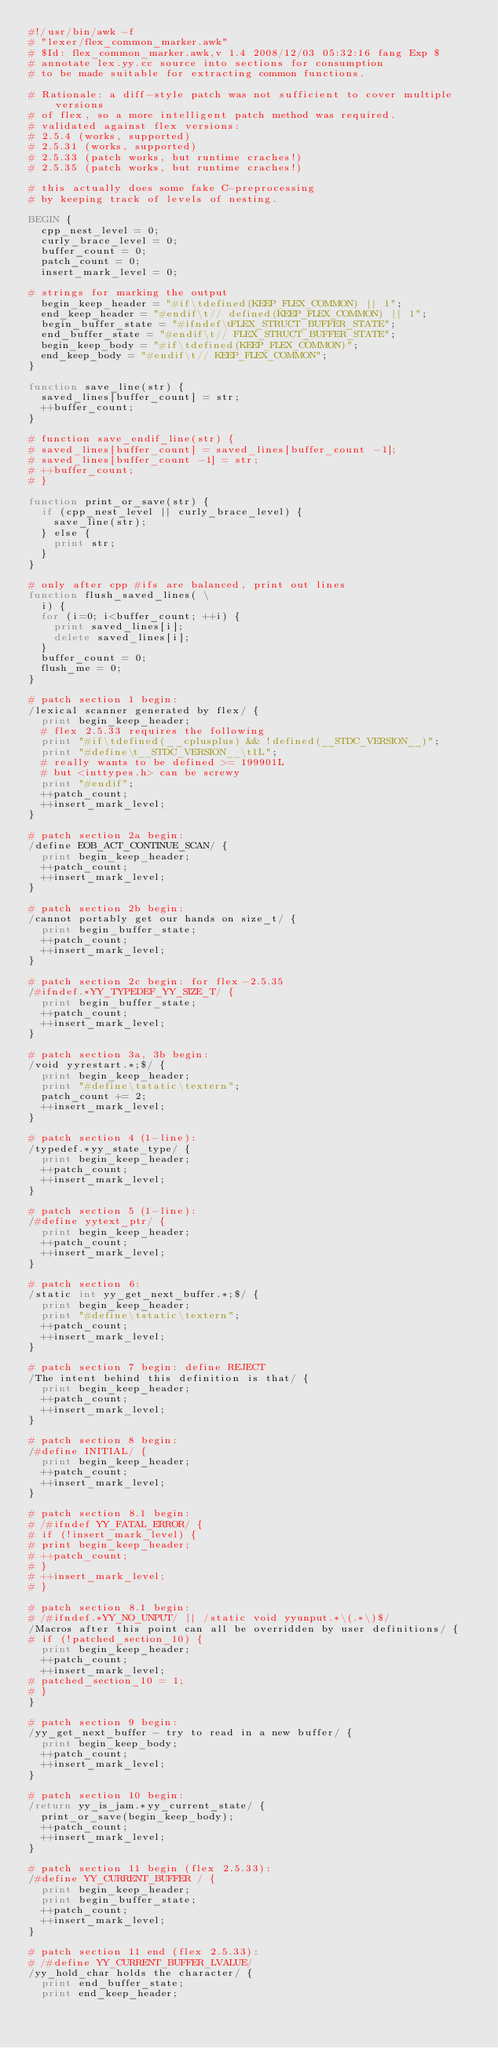Convert code to text. <code><loc_0><loc_0><loc_500><loc_500><_Awk_>#!/usr/bin/awk -f
# "lexer/flex_common_marker.awk"
#	$Id: flex_common_marker.awk,v 1.4 2008/12/03 05:32:16 fang Exp $
# annotate lex.yy.cc source into sections for consumption
# to be made suitable for extracting common functions.

# Rationale: a diff-style patch was not sufficient to cover multiple versions 
# of flex, so a more intelligent patch method was required.  
# validated against flex versions:
# 2.5.4 (works, supported)
# 2.5.31 (works, supported)
# 2.5.33 (patch works, but runtime craches!)
# 2.5.35 (patch works, but runtime craches!)

# this actually does some fake C-preprocessing
# by keeping track of levels of nesting.

BEGIN {
	cpp_nest_level = 0;
	curly_brace_level = 0;
	buffer_count = 0;
	patch_count = 0;
	insert_mark_level = 0;

# strings for marking the output
	begin_keep_header = "#if\tdefined(KEEP_FLEX_COMMON) || 1";
	end_keep_header = "#endif\t// defined(KEEP_FLEX_COMMON) || 1";
	begin_buffer_state = "#ifndef\tFLEX_STRUCT_BUFFER_STATE";
	end_buffer_state = "#endif\t// FLEX_STRUCT_BUFFER_STATE";
	begin_keep_body = "#if\tdefined(KEEP_FLEX_COMMON)";
	end_keep_body = "#endif\t// KEEP_FLEX_COMMON";
}

function save_line(str) {
	saved_lines[buffer_count] = str;
	++buffer_count;
}

# function save_endif_line(str) {
#	saved_lines[buffer_count] = saved_lines[buffer_count -1];
#	saved_lines[buffer_count -1] = str;
#	++buffer_count;
# }

function print_or_save(str) {
	if (cpp_nest_level || curly_brace_level) {
		save_line(str);
	} else {
		print str;
	}
}

# only after cpp #ifs are balanced, print out lines
function flush_saved_lines( \
	i) {
	for (i=0; i<buffer_count; ++i) {
		print saved_lines[i];
		delete saved_lines[i];
	}
	buffer_count = 0;
	flush_me = 0;
}

# patch section 1 begin:
/lexical scanner generated by flex/ {
	print begin_keep_header;
	# flex 2.5.33 requires the following
	print "#if\tdefined(__cplusplus) && !defined(__STDC_VERSION__)";
	print "#define\t__STDC_VERSION__\t1L";
	# really wants to be defined >= 199901L
	# but <inttypes.h> can be screwy
	print "#endif";
	++patch_count;
	++insert_mark_level;
}

# patch section 2a begin:
/define EOB_ACT_CONTINUE_SCAN/ {
	print begin_keep_header;
	++patch_count;
	++insert_mark_level;
}

# patch section 2b begin:
/cannot portably get our hands on size_t/ {
	print begin_buffer_state;
	++patch_count;
	++insert_mark_level;
}

# patch section 2c begin: for flex-2.5.35
/#ifndef.*YY_TYPEDEF_YY_SIZE_T/ {
	print begin_buffer_state;
	++patch_count;
	++insert_mark_level;
}

# patch section 3a, 3b begin:
/void yyrestart.*;$/ {
	print begin_keep_header;
	print "#define\tstatic\textern";
	patch_count += 2;
	++insert_mark_level;
}

# patch section 4 (1-line):
/typedef.*yy_state_type/ {
	print begin_keep_header;
	++patch_count;
	++insert_mark_level;
}

# patch section 5 (1-line):
/#define yytext_ptr/ {
	print begin_keep_header;
	++patch_count;
	++insert_mark_level;
}

# patch section 6:
/static int yy_get_next_buffer.*;$/ {
	print begin_keep_header;
	print "#define\tstatic\textern";
	++patch_count;
	++insert_mark_level;
}

# patch section 7 begin: define REJECT
/The intent behind this definition is that/ {
	print begin_keep_header;
	++patch_count;
	++insert_mark_level;
}

# patch section 8 begin:
/#define INITIAL/ {
	print begin_keep_header;
	++patch_count;
	++insert_mark_level;
}

# patch section 8.1 begin:
# /#ifndef YY_FATAL_ERROR/ {
# if (!insert_mark_level) {
#	print begin_keep_header;
#	++patch_count;
# }
#	++insert_mark_level;
# }

# patch section 8.1 begin:
# /#ifndef.*YY_NO_UNPUT/ || /static void yyunput.*\(.*\)$/
/Macros after this point can all be overridden by user definitions/ {
# if (!patched_section_10) {
	print begin_keep_header;
	++patch_count;
	++insert_mark_level;
#	patched_section_10 = 1;
# }
}

# patch section 9 begin:
/yy_get_next_buffer - try to read in a new buffer/ {
	print begin_keep_body;
	++patch_count;
	++insert_mark_level;
}

# patch section 10 begin:
/return yy_is_jam.*yy_current_state/ {
	print_or_save(begin_keep_body);
	++patch_count;
	++insert_mark_level;
}

# patch section 11 begin (flex 2.5.33):
/#define YY_CURRENT_BUFFER / {
	print begin_keep_header;
	print begin_buffer_state;
	++patch_count;
	++insert_mark_level;
}

# patch section 11 end (flex 2.5.33):
# /#define YY_CURRENT_BUFFER_LVALUE/
/yy_hold_char holds the character/ {
	print end_buffer_state;
	print end_keep_header;</code> 